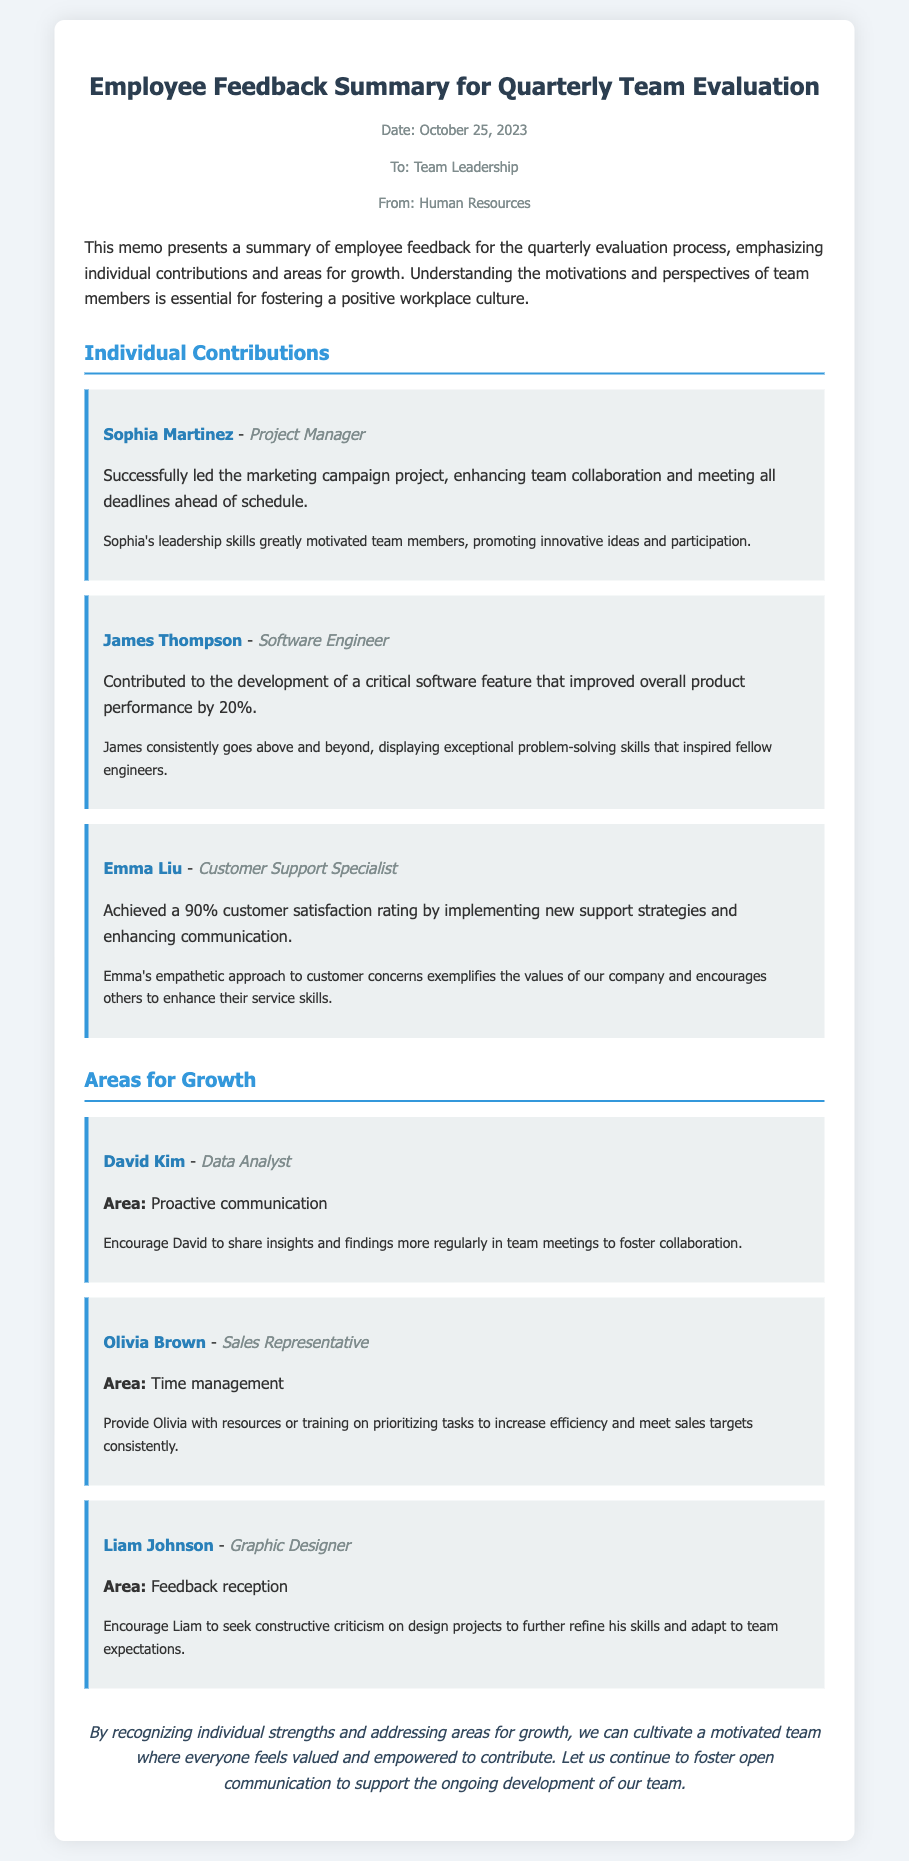What is the date of the memo? The date of the memo is stated in the meta section at the top, which is October 25, 2023.
Answer: October 25, 2023 Who is the Project Manager mentioned in the contributions? The memo lists Sophia Martinez as the Project Manager who made significant contributions.
Answer: Sophia Martinez What was Emma Liu's customer satisfaction rating? The document mentions Emma Liu achieved a 90% customer satisfaction rating.
Answer: 90% Which individual is encouraged to work on proactive communication? The area for growth specifies David Kim is encouraged to improve his proactive communication.
Answer: David Kim What is the role of Liam Johnson? The memo identifies Liam Johnson as a Graphic Designer.
Answer: Graphic Designer How many individuals are highlighted under Areas for Growth? There are three individuals highlighted under Areas for Growth: David Kim, Olivia Brown, and Liam Johnson.
Answer: Three What is the suggested area for Olivia Brown's improvement? The memo specifies that Olivia Brown's area for improvement is in time management.
Answer: Time management What does the conclusion emphasize about team development? The conclusion emphasizes the importance of recognizing strengths and addressing areas for growth to cultivate an empowered team.
Answer: Cultivating an empowered team What is the purpose of the memo? The purpose of the memo is to present a summary of employee feedback for quarterly evaluation, highlighting contributions and growth areas.
Answer: Employee feedback summary for quarterly evaluation 